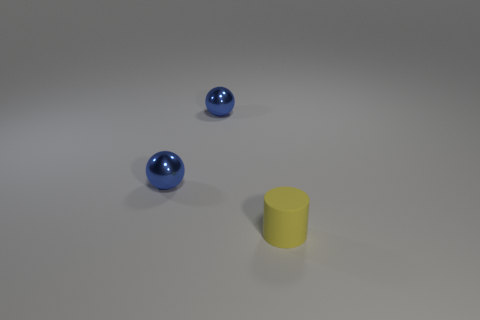Are there any other things that have the same material as the yellow object?
Offer a very short reply. No. What number of blue balls are the same size as the yellow cylinder?
Offer a terse response. 2. How many other objects are the same color as the tiny matte cylinder?
Give a very brief answer. 0. What number of other things are made of the same material as the yellow object?
Make the answer very short. 0. How many cyan things are either small balls or tiny rubber things?
Offer a terse response. 0. What number of metal things are tiny yellow cylinders or blue objects?
Your answer should be very brief. 2. Is there a shiny thing?
Offer a very short reply. Yes. Are there any other things that have the same color as the small cylinder?
Provide a succinct answer. No. Are there any things left of the cylinder?
Offer a terse response. Yes. Is there a blue metallic object that has the same size as the cylinder?
Ensure brevity in your answer.  Yes. 